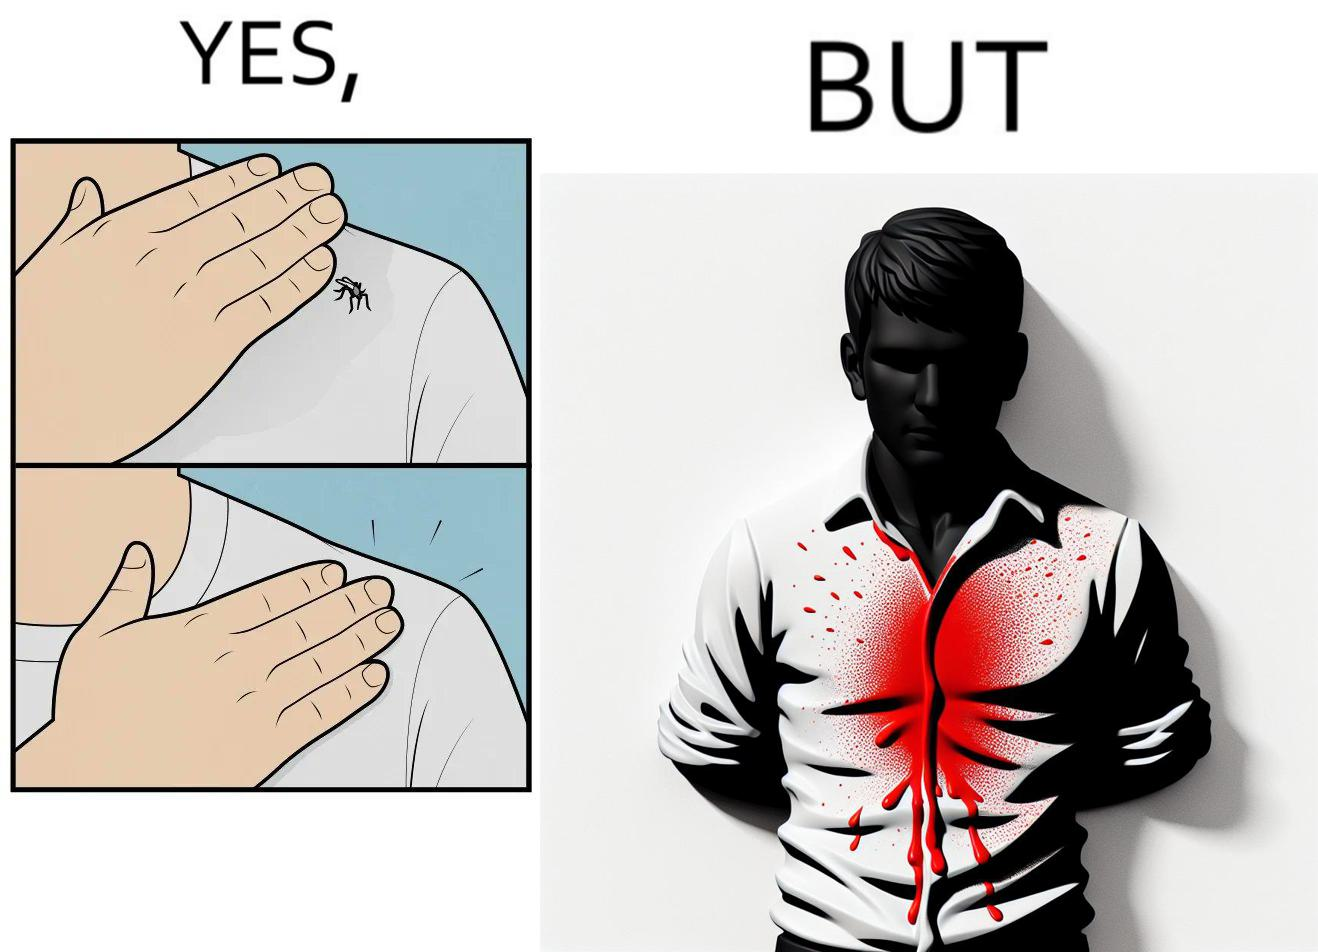Does this image contain satire or humor? Yes, this image is satirical. 